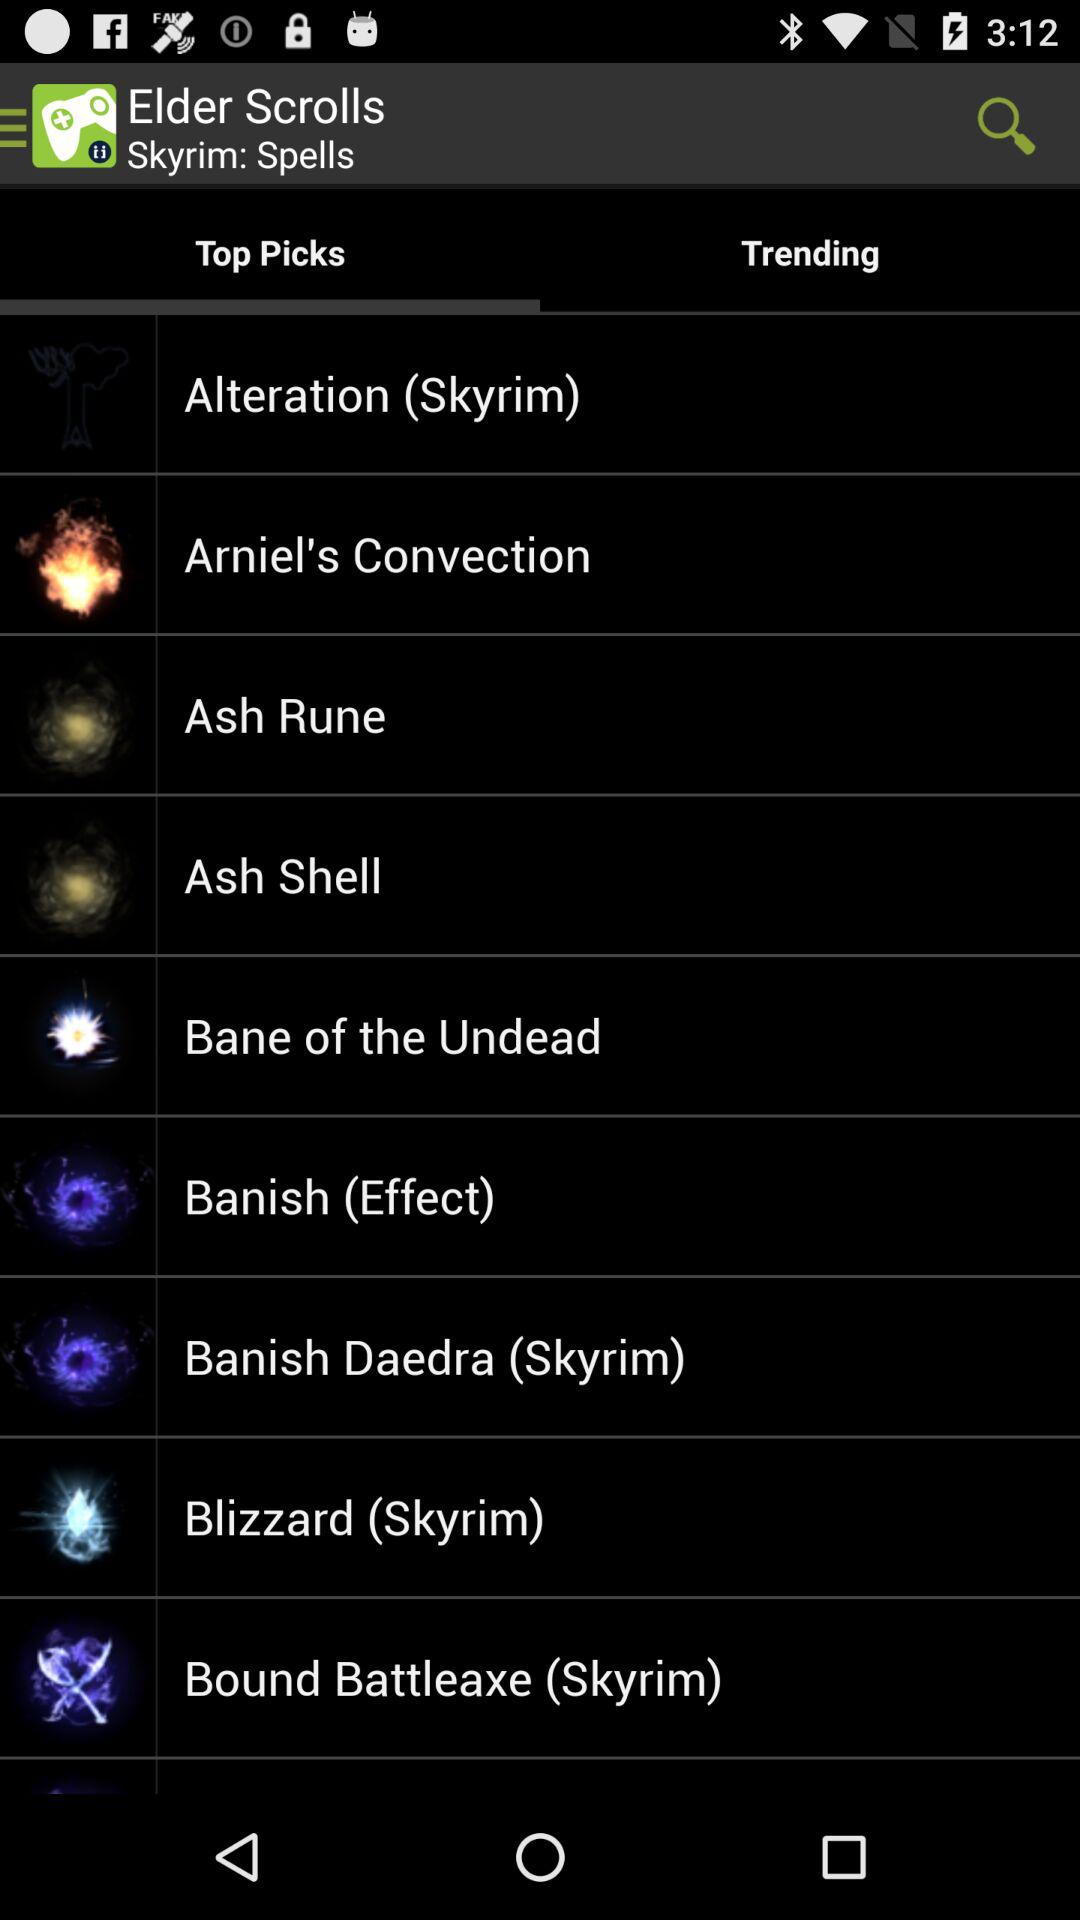What is the selected option in the "Elder Scrolls"? The selected option in the "Elder Scrolls" is "Top Picks". 